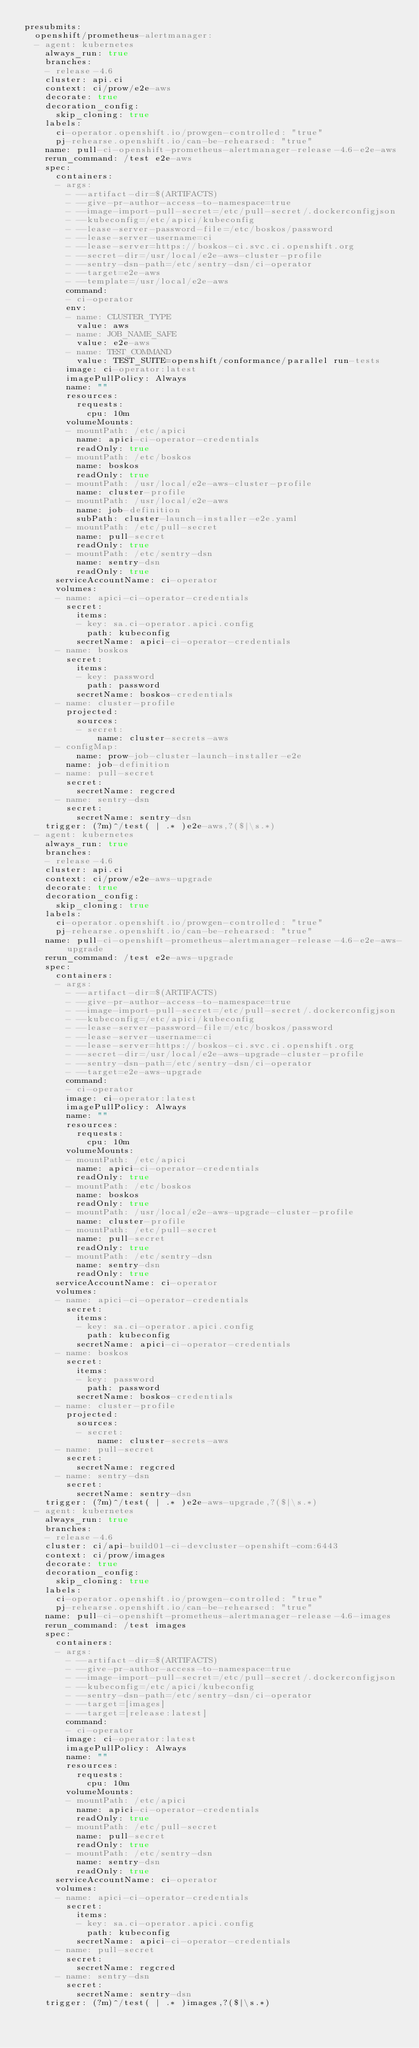<code> <loc_0><loc_0><loc_500><loc_500><_YAML_>presubmits:
  openshift/prometheus-alertmanager:
  - agent: kubernetes
    always_run: true
    branches:
    - release-4.6
    cluster: api.ci
    context: ci/prow/e2e-aws
    decorate: true
    decoration_config:
      skip_cloning: true
    labels:
      ci-operator.openshift.io/prowgen-controlled: "true"
      pj-rehearse.openshift.io/can-be-rehearsed: "true"
    name: pull-ci-openshift-prometheus-alertmanager-release-4.6-e2e-aws
    rerun_command: /test e2e-aws
    spec:
      containers:
      - args:
        - --artifact-dir=$(ARTIFACTS)
        - --give-pr-author-access-to-namespace=true
        - --image-import-pull-secret=/etc/pull-secret/.dockerconfigjson
        - --kubeconfig=/etc/apici/kubeconfig
        - --lease-server-password-file=/etc/boskos/password
        - --lease-server-username=ci
        - --lease-server=https://boskos-ci.svc.ci.openshift.org
        - --secret-dir=/usr/local/e2e-aws-cluster-profile
        - --sentry-dsn-path=/etc/sentry-dsn/ci-operator
        - --target=e2e-aws
        - --template=/usr/local/e2e-aws
        command:
        - ci-operator
        env:
        - name: CLUSTER_TYPE
          value: aws
        - name: JOB_NAME_SAFE
          value: e2e-aws
        - name: TEST_COMMAND
          value: TEST_SUITE=openshift/conformance/parallel run-tests
        image: ci-operator:latest
        imagePullPolicy: Always
        name: ""
        resources:
          requests:
            cpu: 10m
        volumeMounts:
        - mountPath: /etc/apici
          name: apici-ci-operator-credentials
          readOnly: true
        - mountPath: /etc/boskos
          name: boskos
          readOnly: true
        - mountPath: /usr/local/e2e-aws-cluster-profile
          name: cluster-profile
        - mountPath: /usr/local/e2e-aws
          name: job-definition
          subPath: cluster-launch-installer-e2e.yaml
        - mountPath: /etc/pull-secret
          name: pull-secret
          readOnly: true
        - mountPath: /etc/sentry-dsn
          name: sentry-dsn
          readOnly: true
      serviceAccountName: ci-operator
      volumes:
      - name: apici-ci-operator-credentials
        secret:
          items:
          - key: sa.ci-operator.apici.config
            path: kubeconfig
          secretName: apici-ci-operator-credentials
      - name: boskos
        secret:
          items:
          - key: password
            path: password
          secretName: boskos-credentials
      - name: cluster-profile
        projected:
          sources:
          - secret:
              name: cluster-secrets-aws
      - configMap:
          name: prow-job-cluster-launch-installer-e2e
        name: job-definition
      - name: pull-secret
        secret:
          secretName: regcred
      - name: sentry-dsn
        secret:
          secretName: sentry-dsn
    trigger: (?m)^/test( | .* )e2e-aws,?($|\s.*)
  - agent: kubernetes
    always_run: true
    branches:
    - release-4.6
    cluster: api.ci
    context: ci/prow/e2e-aws-upgrade
    decorate: true
    decoration_config:
      skip_cloning: true
    labels:
      ci-operator.openshift.io/prowgen-controlled: "true"
      pj-rehearse.openshift.io/can-be-rehearsed: "true"
    name: pull-ci-openshift-prometheus-alertmanager-release-4.6-e2e-aws-upgrade
    rerun_command: /test e2e-aws-upgrade
    spec:
      containers:
      - args:
        - --artifact-dir=$(ARTIFACTS)
        - --give-pr-author-access-to-namespace=true
        - --image-import-pull-secret=/etc/pull-secret/.dockerconfigjson
        - --kubeconfig=/etc/apici/kubeconfig
        - --lease-server-password-file=/etc/boskos/password
        - --lease-server-username=ci
        - --lease-server=https://boskos-ci.svc.ci.openshift.org
        - --secret-dir=/usr/local/e2e-aws-upgrade-cluster-profile
        - --sentry-dsn-path=/etc/sentry-dsn/ci-operator
        - --target=e2e-aws-upgrade
        command:
        - ci-operator
        image: ci-operator:latest
        imagePullPolicy: Always
        name: ""
        resources:
          requests:
            cpu: 10m
        volumeMounts:
        - mountPath: /etc/apici
          name: apici-ci-operator-credentials
          readOnly: true
        - mountPath: /etc/boskos
          name: boskos
          readOnly: true
        - mountPath: /usr/local/e2e-aws-upgrade-cluster-profile
          name: cluster-profile
        - mountPath: /etc/pull-secret
          name: pull-secret
          readOnly: true
        - mountPath: /etc/sentry-dsn
          name: sentry-dsn
          readOnly: true
      serviceAccountName: ci-operator
      volumes:
      - name: apici-ci-operator-credentials
        secret:
          items:
          - key: sa.ci-operator.apici.config
            path: kubeconfig
          secretName: apici-ci-operator-credentials
      - name: boskos
        secret:
          items:
          - key: password
            path: password
          secretName: boskos-credentials
      - name: cluster-profile
        projected:
          sources:
          - secret:
              name: cluster-secrets-aws
      - name: pull-secret
        secret:
          secretName: regcred
      - name: sentry-dsn
        secret:
          secretName: sentry-dsn
    trigger: (?m)^/test( | .* )e2e-aws-upgrade,?($|\s.*)
  - agent: kubernetes
    always_run: true
    branches:
    - release-4.6
    cluster: ci/api-build01-ci-devcluster-openshift-com:6443
    context: ci/prow/images
    decorate: true
    decoration_config:
      skip_cloning: true
    labels:
      ci-operator.openshift.io/prowgen-controlled: "true"
      pj-rehearse.openshift.io/can-be-rehearsed: "true"
    name: pull-ci-openshift-prometheus-alertmanager-release-4.6-images
    rerun_command: /test images
    spec:
      containers:
      - args:
        - --artifact-dir=$(ARTIFACTS)
        - --give-pr-author-access-to-namespace=true
        - --image-import-pull-secret=/etc/pull-secret/.dockerconfigjson
        - --kubeconfig=/etc/apici/kubeconfig
        - --sentry-dsn-path=/etc/sentry-dsn/ci-operator
        - --target=[images]
        - --target=[release:latest]
        command:
        - ci-operator
        image: ci-operator:latest
        imagePullPolicy: Always
        name: ""
        resources:
          requests:
            cpu: 10m
        volumeMounts:
        - mountPath: /etc/apici
          name: apici-ci-operator-credentials
          readOnly: true
        - mountPath: /etc/pull-secret
          name: pull-secret
          readOnly: true
        - mountPath: /etc/sentry-dsn
          name: sentry-dsn
          readOnly: true
      serviceAccountName: ci-operator
      volumes:
      - name: apici-ci-operator-credentials
        secret:
          items:
          - key: sa.ci-operator.apici.config
            path: kubeconfig
          secretName: apici-ci-operator-credentials
      - name: pull-secret
        secret:
          secretName: regcred
      - name: sentry-dsn
        secret:
          secretName: sentry-dsn
    trigger: (?m)^/test( | .* )images,?($|\s.*)
</code> 